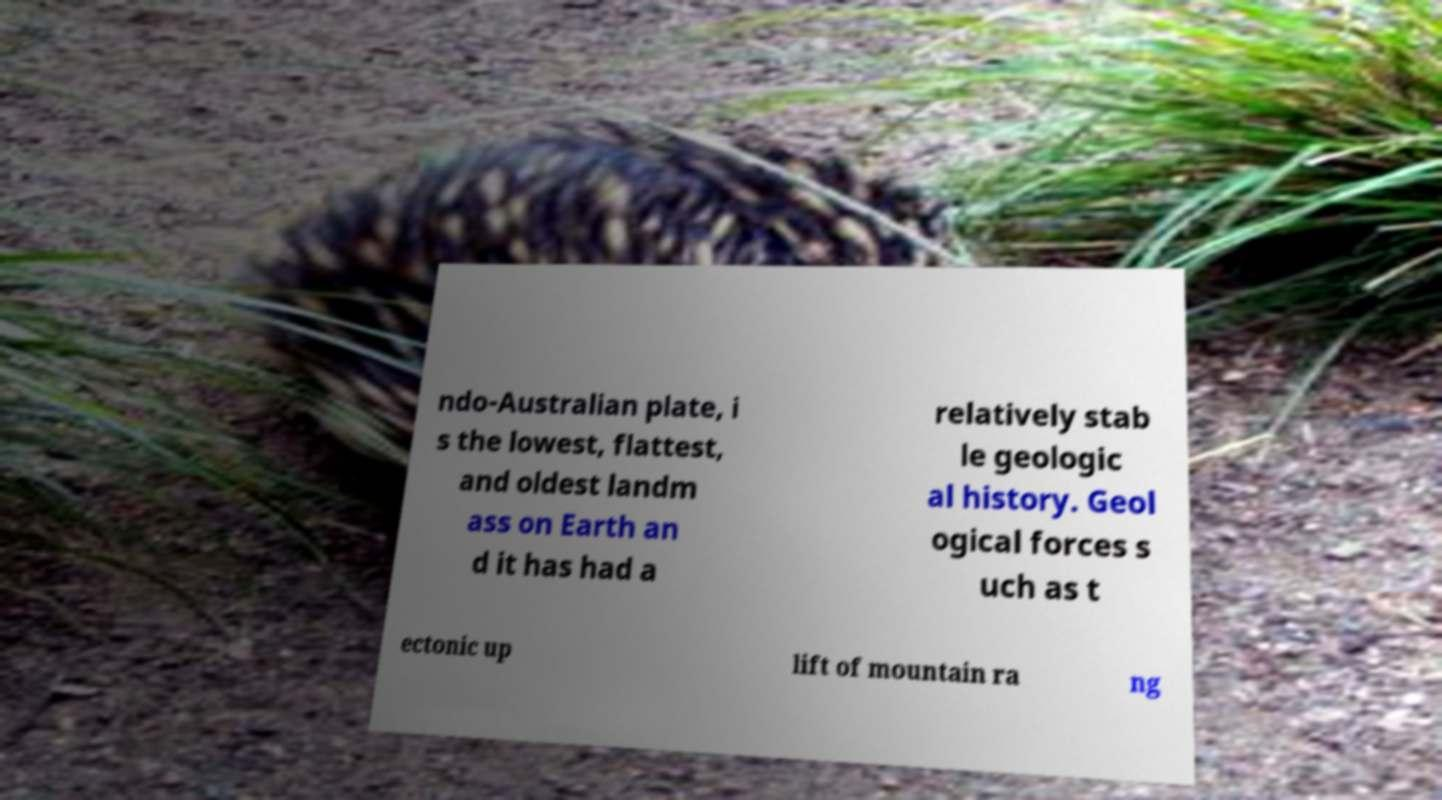Could you extract and type out the text from this image? ndo-Australian plate, i s the lowest, flattest, and oldest landm ass on Earth an d it has had a relatively stab le geologic al history. Geol ogical forces s uch as t ectonic up lift of mountain ra ng 